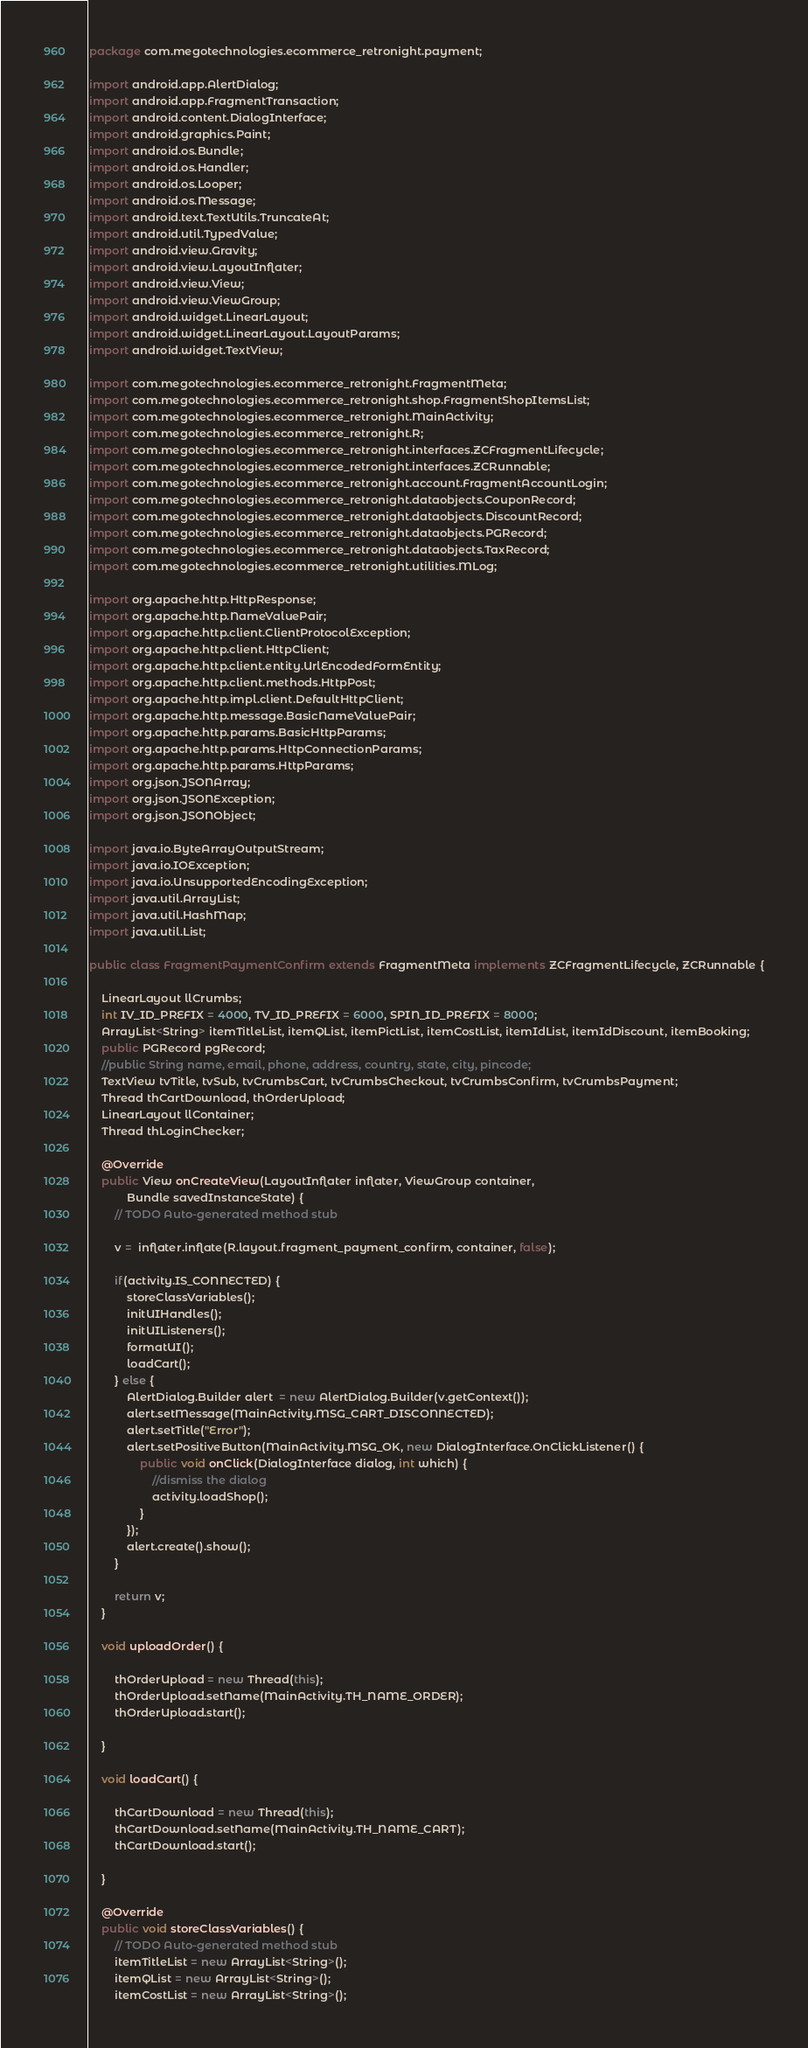Convert code to text. <code><loc_0><loc_0><loc_500><loc_500><_Java_>package com.megotechnologies.ecommerce_retronight.payment;

import android.app.AlertDialog;
import android.app.FragmentTransaction;
import android.content.DialogInterface;
import android.graphics.Paint;
import android.os.Bundle;
import android.os.Handler;
import android.os.Looper;
import android.os.Message;
import android.text.TextUtils.TruncateAt;
import android.util.TypedValue;
import android.view.Gravity;
import android.view.LayoutInflater;
import android.view.View;
import android.view.ViewGroup;
import android.widget.LinearLayout;
import android.widget.LinearLayout.LayoutParams;
import android.widget.TextView;

import com.megotechnologies.ecommerce_retronight.FragmentMeta;
import com.megotechnologies.ecommerce_retronight.shop.FragmentShopItemsList;
import com.megotechnologies.ecommerce_retronight.MainActivity;
import com.megotechnologies.ecommerce_retronight.R;
import com.megotechnologies.ecommerce_retronight.interfaces.ZCFragmentLifecycle;
import com.megotechnologies.ecommerce_retronight.interfaces.ZCRunnable;
import com.megotechnologies.ecommerce_retronight.account.FragmentAccountLogin;
import com.megotechnologies.ecommerce_retronight.dataobjects.CouponRecord;
import com.megotechnologies.ecommerce_retronight.dataobjects.DiscountRecord;
import com.megotechnologies.ecommerce_retronight.dataobjects.PGRecord;
import com.megotechnologies.ecommerce_retronight.dataobjects.TaxRecord;
import com.megotechnologies.ecommerce_retronight.utilities.MLog;

import org.apache.http.HttpResponse;
import org.apache.http.NameValuePair;
import org.apache.http.client.ClientProtocolException;
import org.apache.http.client.HttpClient;
import org.apache.http.client.entity.UrlEncodedFormEntity;
import org.apache.http.client.methods.HttpPost;
import org.apache.http.impl.client.DefaultHttpClient;
import org.apache.http.message.BasicNameValuePair;
import org.apache.http.params.BasicHttpParams;
import org.apache.http.params.HttpConnectionParams;
import org.apache.http.params.HttpParams;
import org.json.JSONArray;
import org.json.JSONException;
import org.json.JSONObject;

import java.io.ByteArrayOutputStream;
import java.io.IOException;
import java.io.UnsupportedEncodingException;
import java.util.ArrayList;
import java.util.HashMap;
import java.util.List;

public class FragmentPaymentConfirm extends FragmentMeta implements ZCFragmentLifecycle, ZCRunnable {

	LinearLayout llCrumbs;
	int IV_ID_PREFIX = 4000, TV_ID_PREFIX = 6000, SPIN_ID_PREFIX = 8000;
	ArrayList<String> itemTitleList, itemQList, itemPictList, itemCostList, itemIdList, itemIdDiscount, itemBooking;
	public PGRecord pgRecord;
	//public String name, email, phone, address, country, state, city, pincode;
	TextView tvTitle, tvSub, tvCrumbsCart, tvCrumbsCheckout, tvCrumbsConfirm, tvCrumbsPayment;
	Thread thCartDownload, thOrderUpload;
	LinearLayout llContainer;
	Thread thLoginChecker;

	@Override
	public View onCreateView(LayoutInflater inflater, ViewGroup container,
			Bundle savedInstanceState) {
		// TODO Auto-generated method stub

		v =  inflater.inflate(R.layout.fragment_payment_confirm, container, false);

		if(activity.IS_CONNECTED) {
			storeClassVariables();
			initUIHandles();
			initUIListeners();
			formatUI();
			loadCart();
		} else {
			AlertDialog.Builder alert  = new AlertDialog.Builder(v.getContext());
			alert.setMessage(MainActivity.MSG_CART_DISCONNECTED);
			alert.setTitle("Error");
			alert.setPositiveButton(MainActivity.MSG_OK, new DialogInterface.OnClickListener() {
				public void onClick(DialogInterface dialog, int which) {
					//dismiss the dialog
					activity.loadShop();
				}
			});
			alert.create().show();
		}

		return v;
	}

	void uploadOrder() {

		thOrderUpload = new Thread(this);
		thOrderUpload.setName(MainActivity.TH_NAME_ORDER);
		thOrderUpload.start();

	}

	void loadCart() {

		thCartDownload = new Thread(this);
		thCartDownload.setName(MainActivity.TH_NAME_CART);
		thCartDownload.start();

	}

	@Override
	public void storeClassVariables() {
		// TODO Auto-generated method stub
		itemTitleList = new ArrayList<String>();
		itemQList = new ArrayList<String>();
		itemCostList = new ArrayList<String>();</code> 